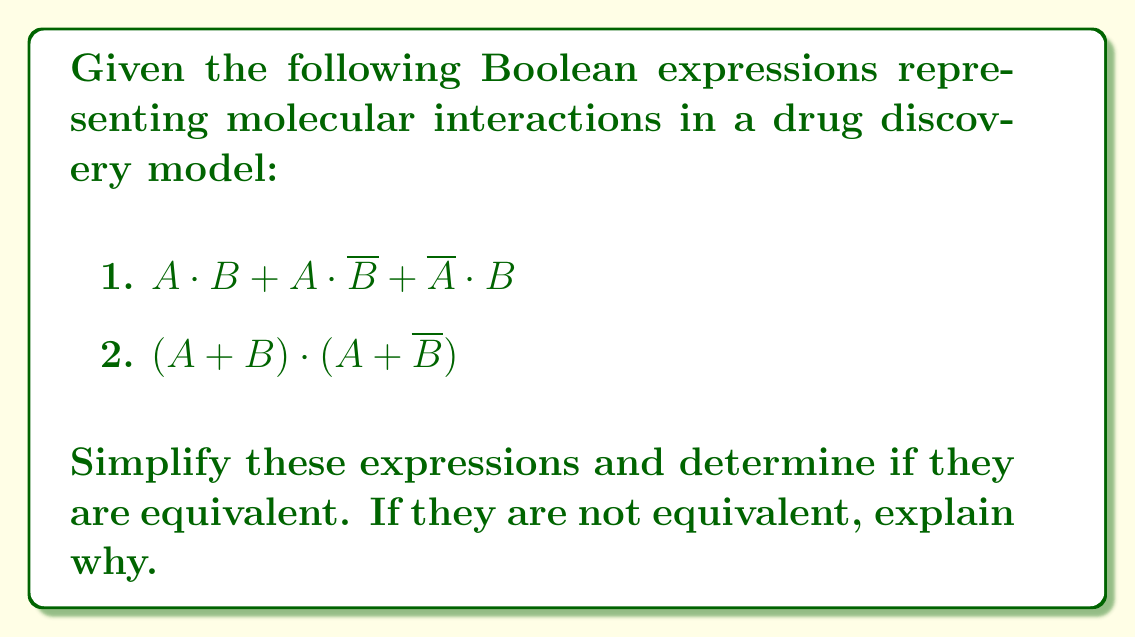Show me your answer to this math problem. Let's simplify each expression step-by-step:

1. $A \cdot B + A \cdot \overline{B} + \overline{A} \cdot B$

Step 1: Apply the distributive law
$= A \cdot (B + \overline{B}) + \overline{A} \cdot B$

Step 2: Simplify $(B + \overline{B})$ to 1 (law of excluded middle)
$= A \cdot 1 + \overline{A} \cdot B$

Step 3: Simplify $A \cdot 1$ to $A$
$= A + \overline{A} \cdot B$

This is the simplified form of the first expression.

2. $(A + B) \cdot (A + \overline{B})$

Step 1: Apply the distributive law
$= A \cdot A + A \cdot \overline{B} + B \cdot A + B \cdot \overline{B}$

Step 2: Simplify $A \cdot A$ to $A$ and $B \cdot \overline{B}$ to 0
$= A + A \cdot \overline{B} + B \cdot A + 0$

Step 3: Remove the 0 term
$= A + A \cdot \overline{B} + B \cdot A$

Step 4: Combine $A \cdot \overline{B}$ and $B \cdot A$ using the commutative law
$= A + A \cdot \overline{B} + A \cdot B$

Step 5: Factor out $A$
$= A \cdot (1 + \overline{B} + B)$

Step 6: Simplify $(\overline{B} + B)$ to 1
$= A \cdot (1 + 1)$

Step 7: Simplify $(1 + 1)$ to 1
$= A$

Now, comparing the simplified forms:
Expression 1: $A + \overline{A} \cdot B$
Expression 2: $A$

These expressions are not equivalent. Expression 1 includes the term $\overline{A} \cdot B$, which allows for the possibility of $B$ being true when $A$ is false. Expression 2 is simply $A$, which is true only when $A$ is true, regardless of $B$.

In the context of molecular interactions, this difference could represent a scenario where the second model (Expression 2) might miss potential interactions that occur when molecule $A$ is absent but molecule $B$ is present, which the first model (Expression 1) would capture.
Answer: Not equivalent; $A + \overline{A} \cdot B \neq A$ 